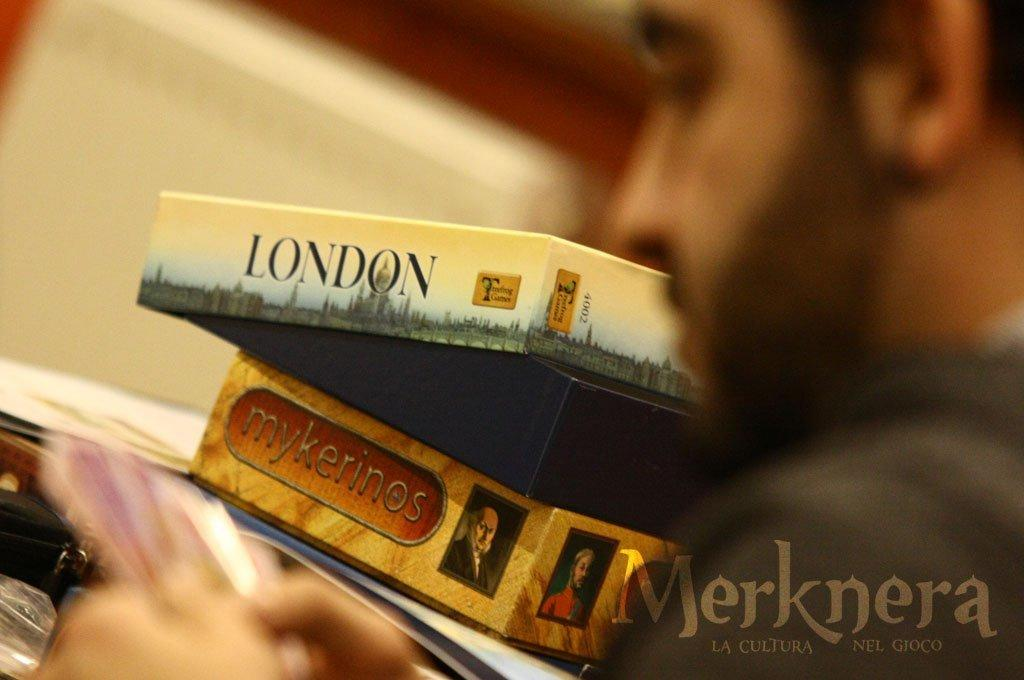Who is present in the image? There is a man in the image. What is in front of the man? There are boxes in front of the man. Where can text be found in the image? Text can be found in the bottom right-hand corner of the image. What type of dress is the man wearing in the image? The man is not wearing a dress in the image; he is wearing regular clothing. Can you see a house in the background of the image? There is no house visible in the image. --- Facts: 1. There is a car in the image. 2. The car is red. 3. The car has four wheels. 4. There are people in the car. 5. The car is parked on the street. Absurd Topics: bird, flower, ocean Conversation: What is the main subject of the image? The main subject of the image is a car. What color is the car? The car is red. How many wheels does the car have? The car has four wheels. Are there any passengers in the car? Yes, there are people in the car. Where is the car located in the image? The car is parked on the street. Reasoning: Let's think step by step in order to produce the conversation. We start by identifying the main subject in the image, which is the car. Then, we expand the conversation to include other details about the car, such as its color and the number of wheels. Next, we mention the presence of passengers in the car and their location. Finally, we describe the car's position in the image, which is parked on the street. Each question is designed to elicit a specific detail about the image that is known from the provided facts. Absurd Question/Answer: What type of bird can be seen flying over the ocean in the image? There is no bird or ocean present in the image; it features a red car parked on the street with people inside. 